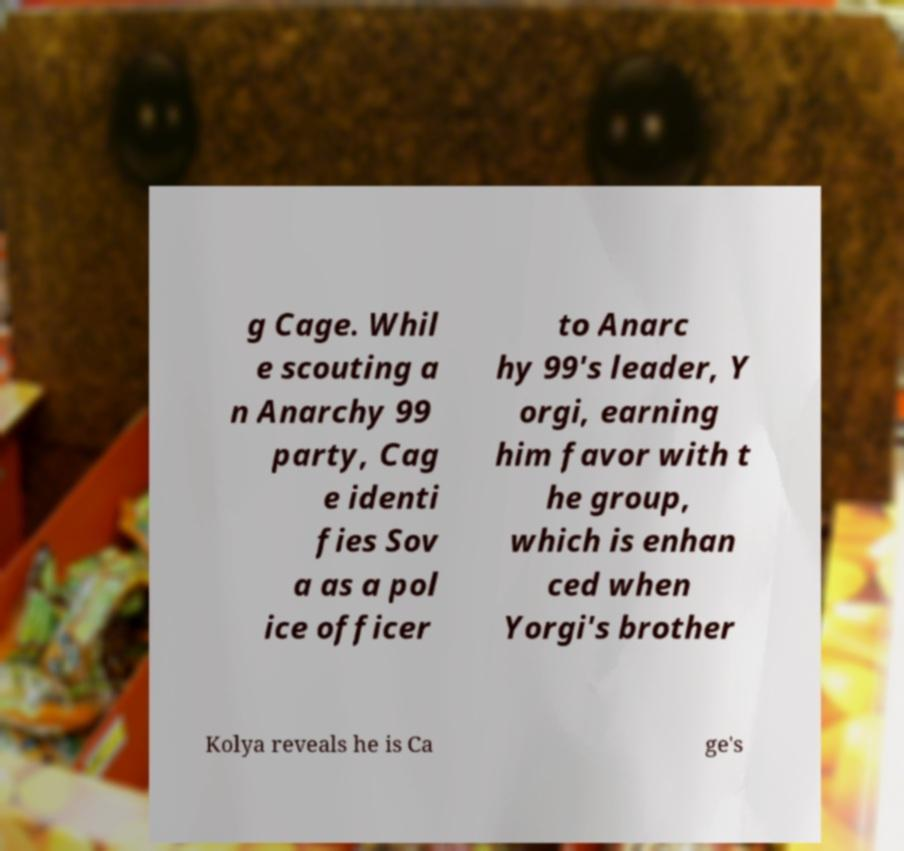For documentation purposes, I need the text within this image transcribed. Could you provide that? g Cage. Whil e scouting a n Anarchy 99 party, Cag e identi fies Sov a as a pol ice officer to Anarc hy 99's leader, Y orgi, earning him favor with t he group, which is enhan ced when Yorgi's brother Kolya reveals he is Ca ge's 